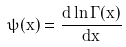Convert formula to latex. <formula><loc_0><loc_0><loc_500><loc_500>\psi ( x ) = \frac { d \ln \Gamma ( x ) } { d x }</formula> 